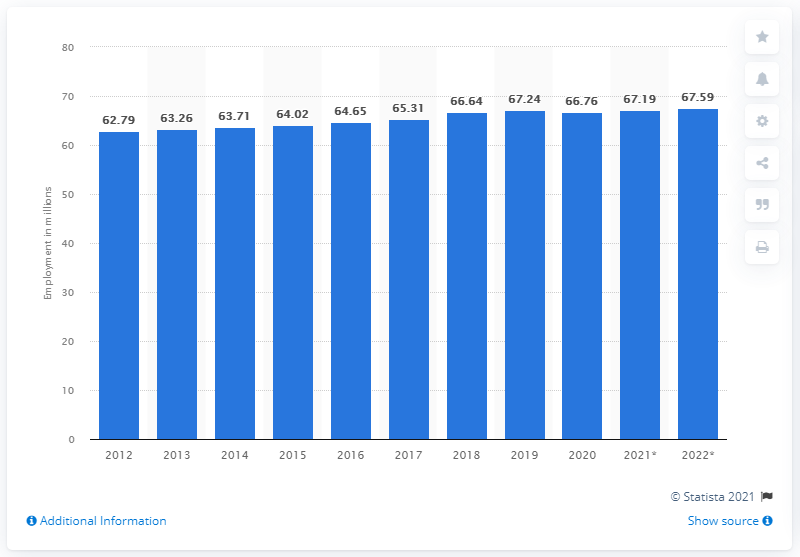Indicate a few pertinent items in this graphic. The employment in Japan ended in 2020. In 2020, there were approximately 67.19 million people employed in Japan. The employment in Japan ended in 2020. 